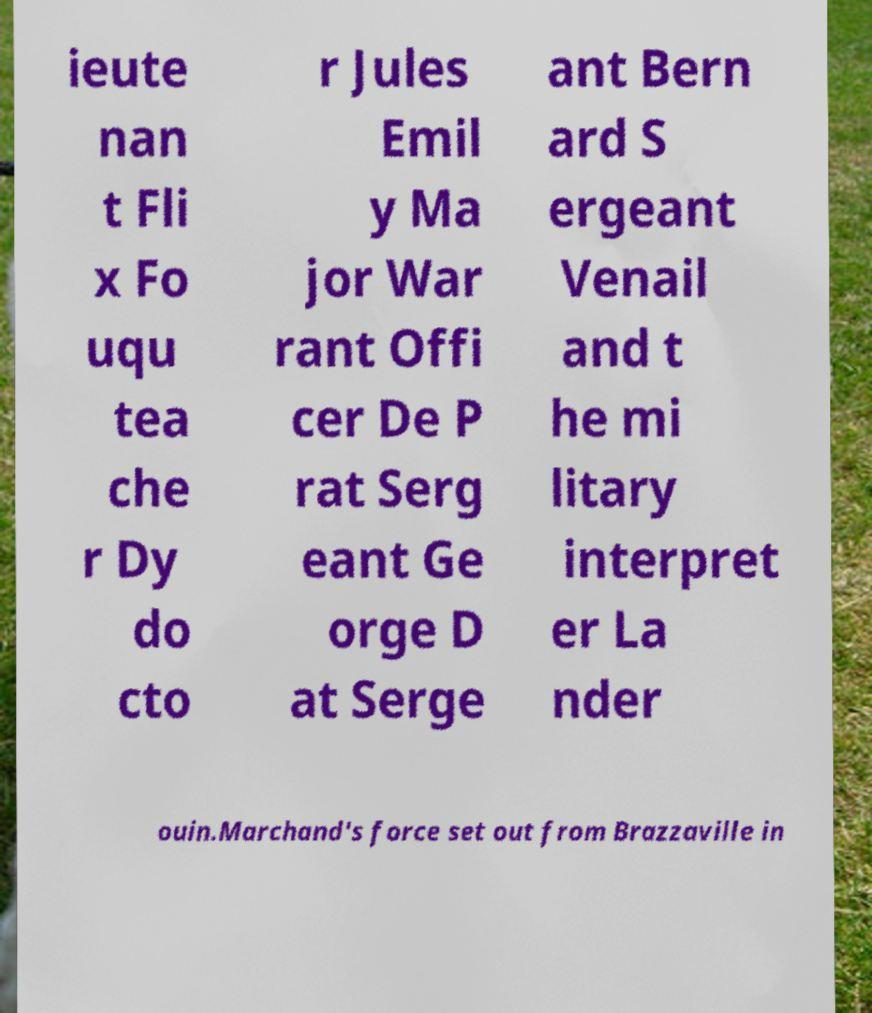I need the written content from this picture converted into text. Can you do that? ieute nan t Fli x Fo uqu tea che r Dy do cto r Jules Emil y Ma jor War rant Offi cer De P rat Serg eant Ge orge D at Serge ant Bern ard S ergeant Venail and t he mi litary interpret er La nder ouin.Marchand's force set out from Brazzaville in 